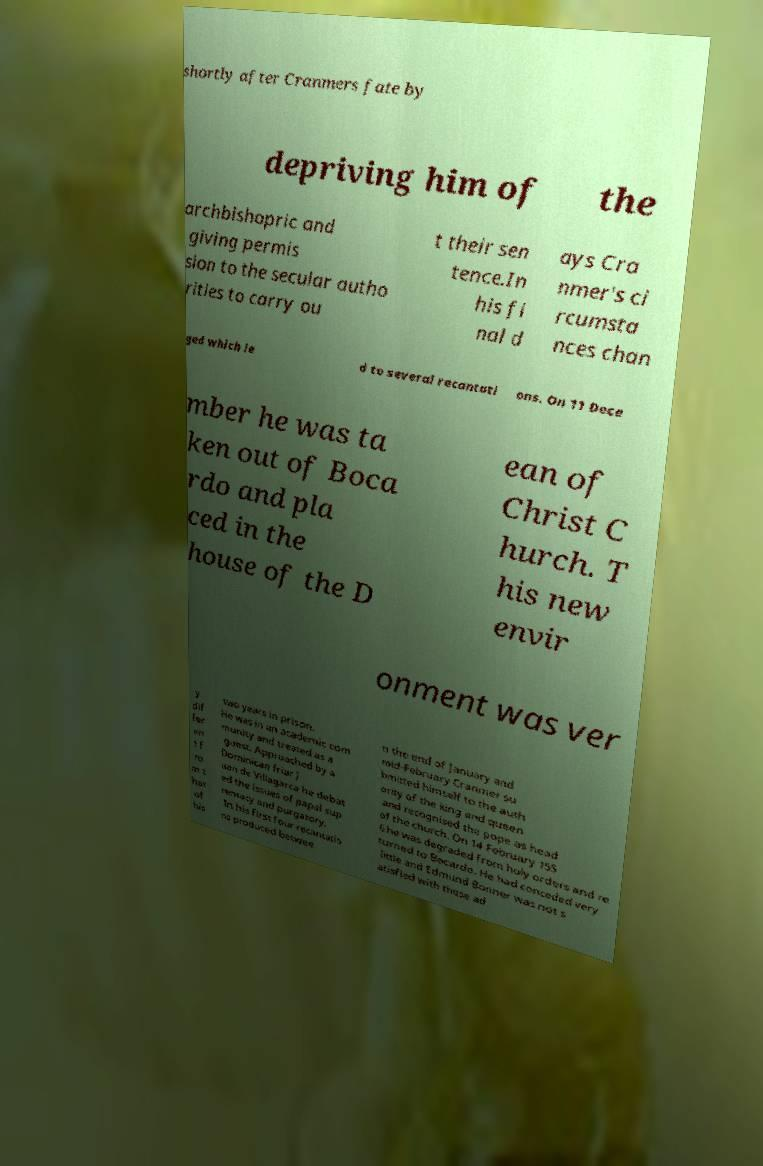Could you extract and type out the text from this image? shortly after Cranmers fate by depriving him of the archbishopric and giving permis sion to the secular autho rities to carry ou t their sen tence.In his fi nal d ays Cra nmer's ci rcumsta nces chan ged which le d to several recantati ons. On 11 Dece mber he was ta ken out of Boca rdo and pla ced in the house of the D ean of Christ C hurch. T his new envir onment was ver y dif fer en t f ro m t hat of his two years in prison. He was in an academic com munity and treated as a guest. Approached by a Dominican friar J uan de Villagarca he debat ed the issues of papal sup remacy and purgatory. In his first four recantatio ns produced betwee n the end of January and mid-February Cranmer su bmitted himself to the auth ority of the king and queen and recognised the pope as head of the church. On 14 February 155 6 he was degraded from holy orders and re turned to Bocardo. He had conceded very little and Edmund Bonner was not s atisfied with these ad 